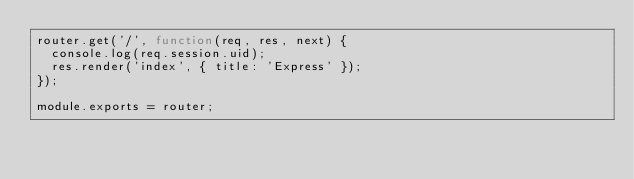Convert code to text. <code><loc_0><loc_0><loc_500><loc_500><_JavaScript_>router.get('/', function(req, res, next) {
  console.log(req.session.uid);
  res.render('index', { title: 'Express' });
});

module.exports = router;
</code> 